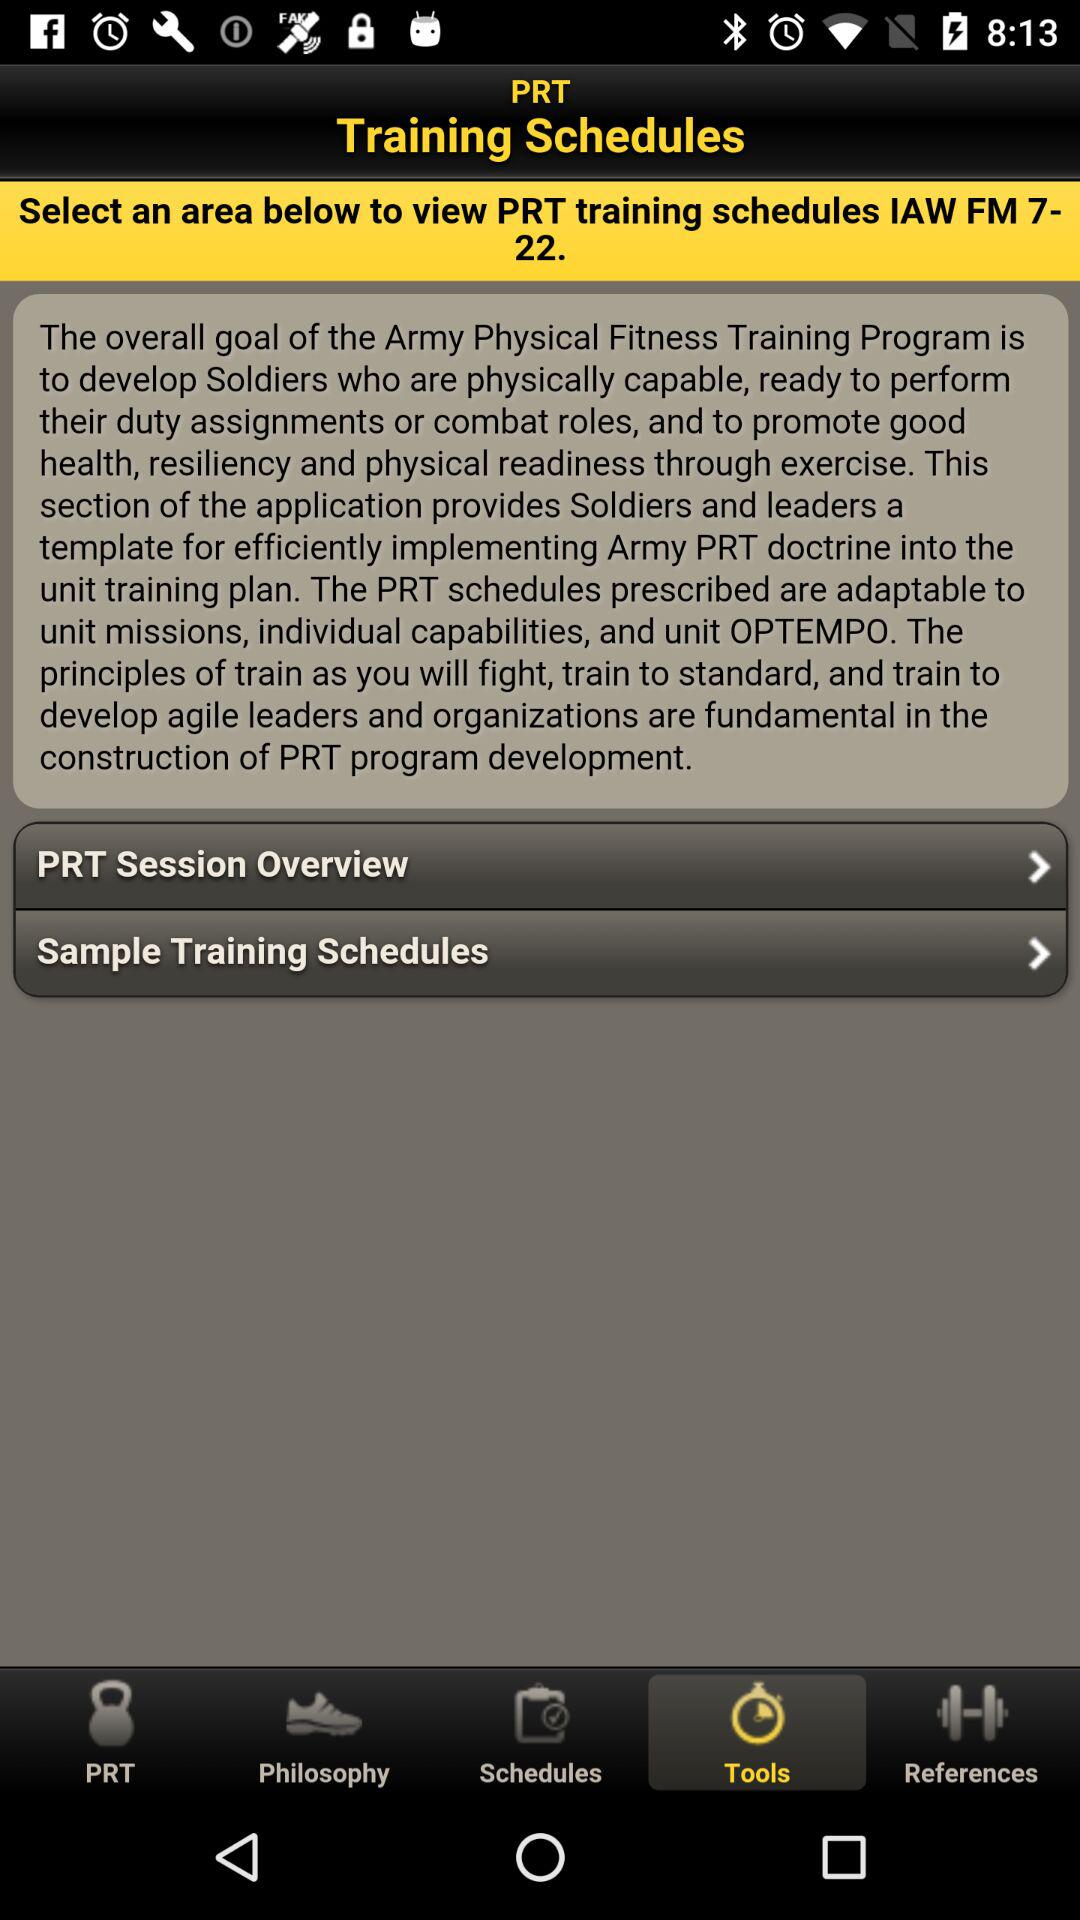When is the training scheduled?
When the provided information is insufficient, respond with <no answer>. <no answer> 